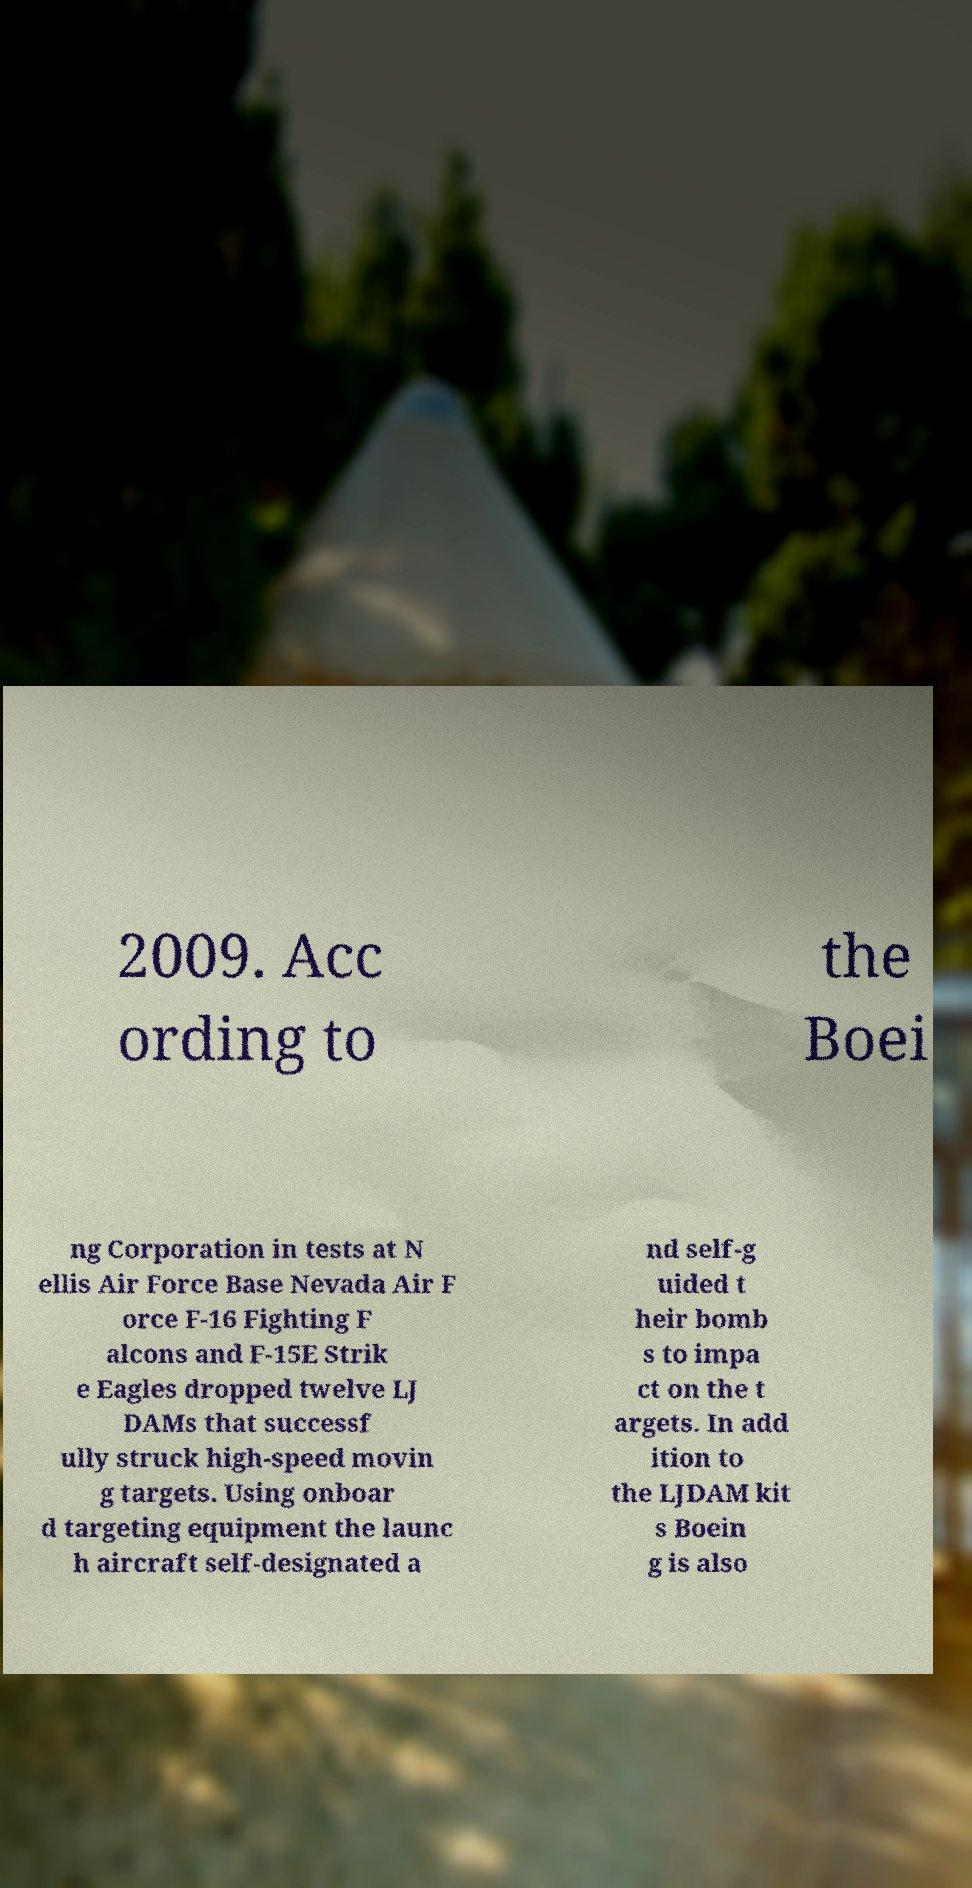Please identify and transcribe the text found in this image. 2009. Acc ording to the Boei ng Corporation in tests at N ellis Air Force Base Nevada Air F orce F-16 Fighting F alcons and F-15E Strik e Eagles dropped twelve LJ DAMs that successf ully struck high-speed movin g targets. Using onboar d targeting equipment the launc h aircraft self-designated a nd self-g uided t heir bomb s to impa ct on the t argets. In add ition to the LJDAM kit s Boein g is also 